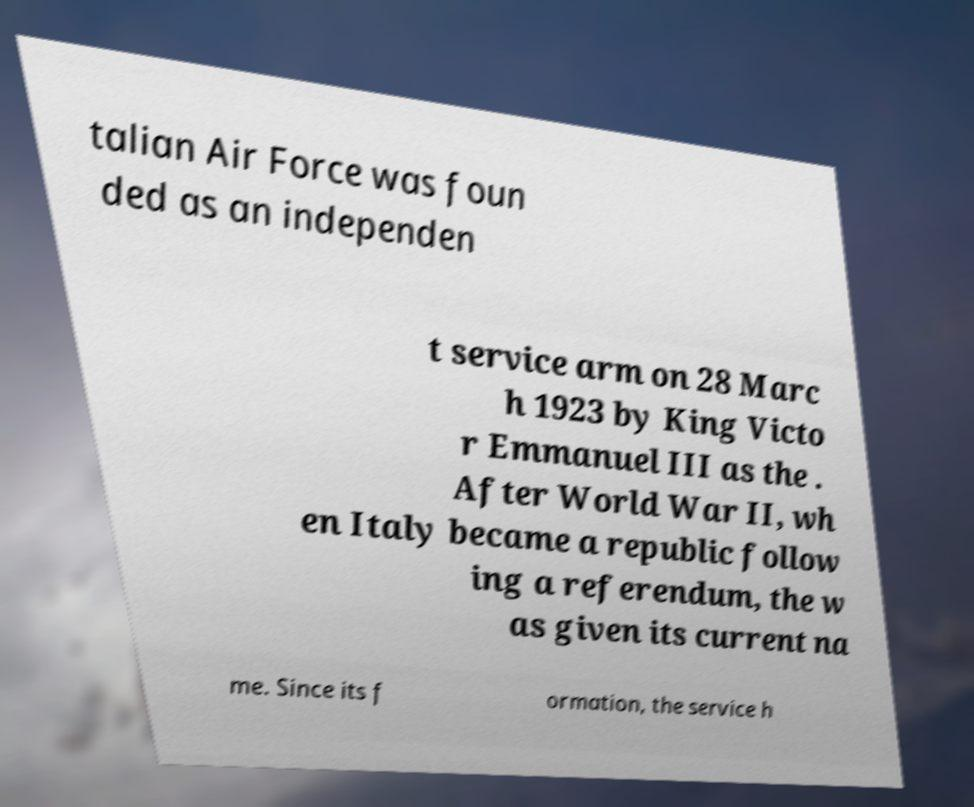Could you assist in decoding the text presented in this image and type it out clearly? talian Air Force was foun ded as an independen t service arm on 28 Marc h 1923 by King Victo r Emmanuel III as the . After World War II, wh en Italy became a republic follow ing a referendum, the w as given its current na me. Since its f ormation, the service h 